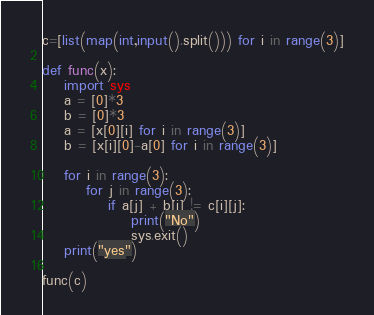Convert code to text. <code><loc_0><loc_0><loc_500><loc_500><_Python_>c=[list(map(int,input().split())) for i in range(3)]

def func(x):
    import sys
    a = [0]*3
    b = [0]*3
    a = [x[0][i] for i in range(3)]
    b = [x[i][0]-a[0] for i in range(3)]

    for i in range(3):
        for j in range(3):
            if a[j] + b[i] != c[i][j]:
                print("No")
                sys.exit()
    print("yes")

func(c)</code> 